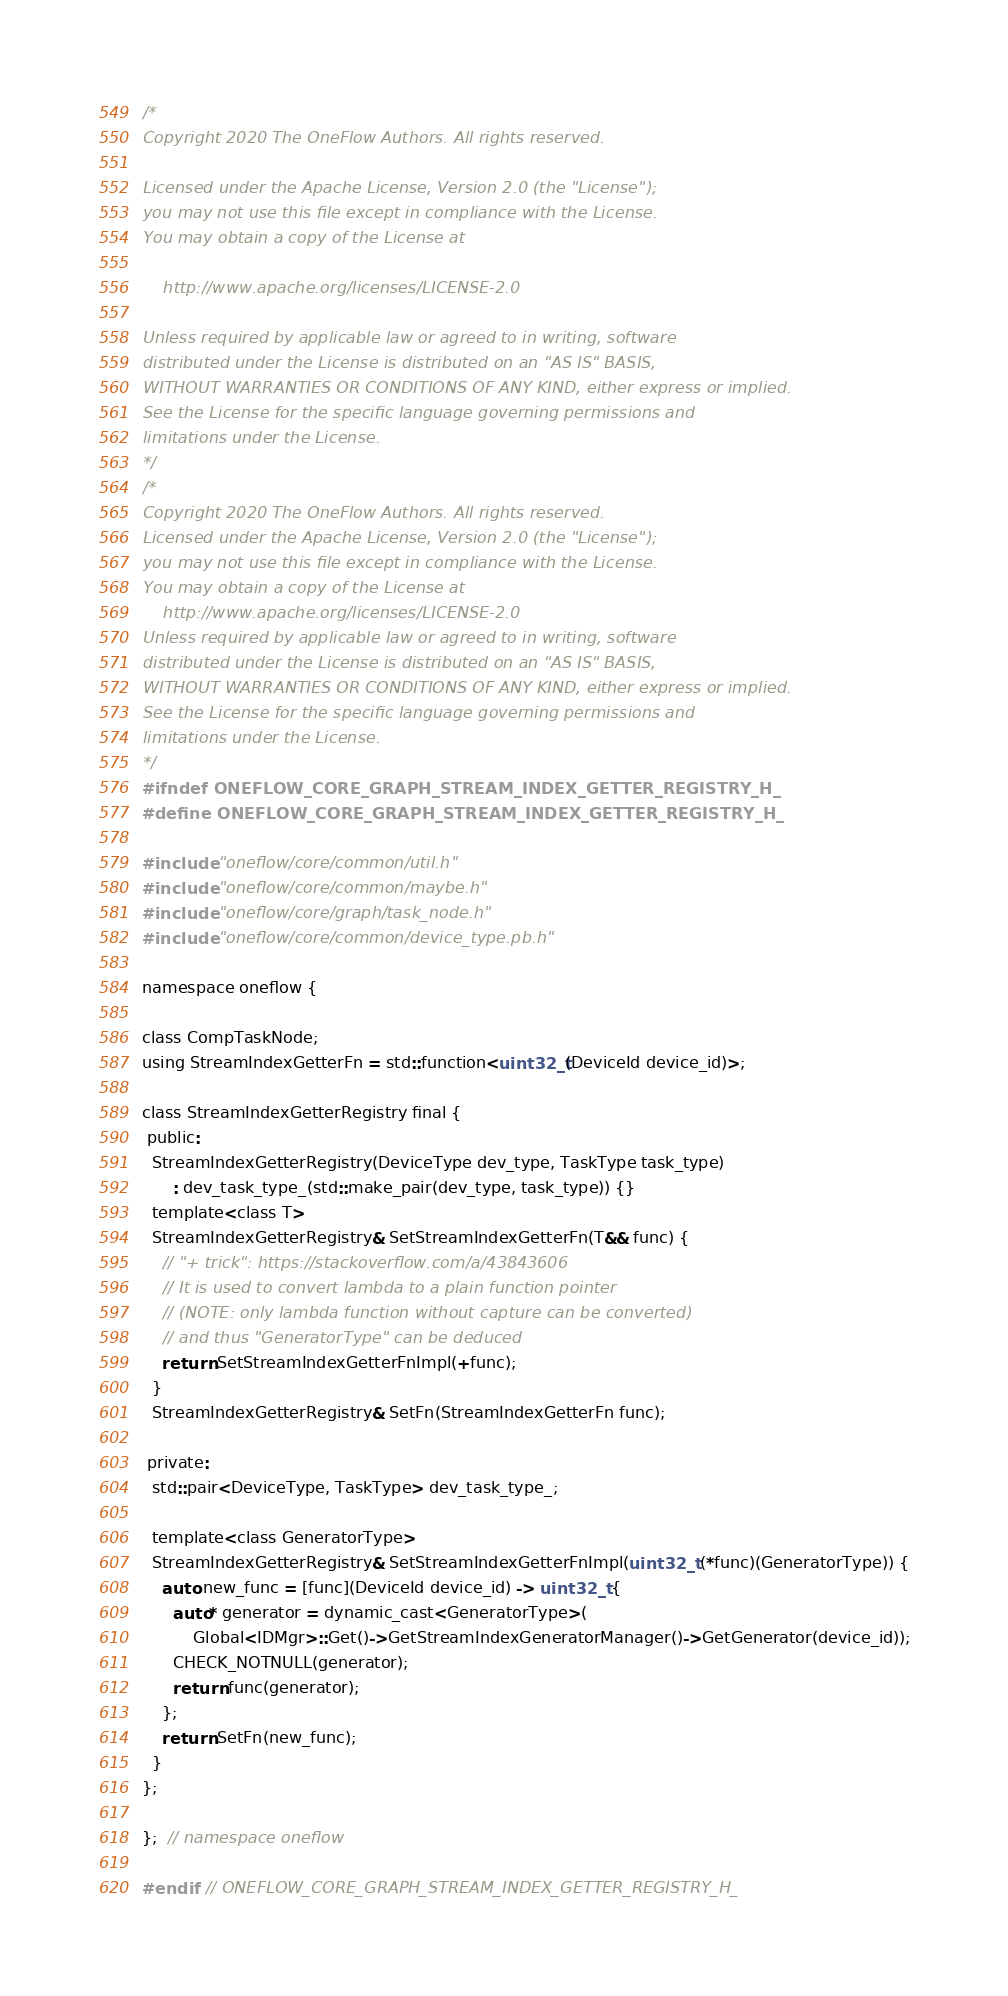Convert code to text. <code><loc_0><loc_0><loc_500><loc_500><_C_>/*
Copyright 2020 The OneFlow Authors. All rights reserved.

Licensed under the Apache License, Version 2.0 (the "License");
you may not use this file except in compliance with the License.
You may obtain a copy of the License at

    http://www.apache.org/licenses/LICENSE-2.0

Unless required by applicable law or agreed to in writing, software
distributed under the License is distributed on an "AS IS" BASIS,
WITHOUT WARRANTIES OR CONDITIONS OF ANY KIND, either express or implied.
See the License for the specific language governing permissions and
limitations under the License.
*/
/*
Copyright 2020 The OneFlow Authors. All rights reserved.
Licensed under the Apache License, Version 2.0 (the "License");
you may not use this file except in compliance with the License.
You may obtain a copy of the License at
    http://www.apache.org/licenses/LICENSE-2.0
Unless required by applicable law or agreed to in writing, software
distributed under the License is distributed on an "AS IS" BASIS,
WITHOUT WARRANTIES OR CONDITIONS OF ANY KIND, either express or implied.
See the License for the specific language governing permissions and
limitations under the License.
*/
#ifndef ONEFLOW_CORE_GRAPH_STREAM_INDEX_GETTER_REGISTRY_H_
#define ONEFLOW_CORE_GRAPH_STREAM_INDEX_GETTER_REGISTRY_H_

#include "oneflow/core/common/util.h"
#include "oneflow/core/common/maybe.h"
#include "oneflow/core/graph/task_node.h"
#include "oneflow/core/common/device_type.pb.h"

namespace oneflow {

class CompTaskNode;
using StreamIndexGetterFn = std::function<uint32_t(DeviceId device_id)>;

class StreamIndexGetterRegistry final {
 public:
  StreamIndexGetterRegistry(DeviceType dev_type, TaskType task_type)
      : dev_task_type_(std::make_pair(dev_type, task_type)) {}
  template<class T>
  StreamIndexGetterRegistry& SetStreamIndexGetterFn(T&& func) {
    // "+ trick": https://stackoverflow.com/a/43843606
    // It is used to convert lambda to a plain function pointer
    // (NOTE: only lambda function without capture can be converted)
    // and thus "GeneratorType" can be deduced
    return SetStreamIndexGetterFnImpl(+func);
  }
  StreamIndexGetterRegistry& SetFn(StreamIndexGetterFn func);

 private:
  std::pair<DeviceType, TaskType> dev_task_type_;

  template<class GeneratorType>
  StreamIndexGetterRegistry& SetStreamIndexGetterFnImpl(uint32_t (*func)(GeneratorType)) {
    auto new_func = [func](DeviceId device_id) -> uint32_t {
      auto* generator = dynamic_cast<GeneratorType>(
          Global<IDMgr>::Get()->GetStreamIndexGeneratorManager()->GetGenerator(device_id));
      CHECK_NOTNULL(generator);
      return func(generator);
    };
    return SetFn(new_func);
  }
};

};  // namespace oneflow

#endif  // ONEFLOW_CORE_GRAPH_STREAM_INDEX_GETTER_REGISTRY_H_
</code> 